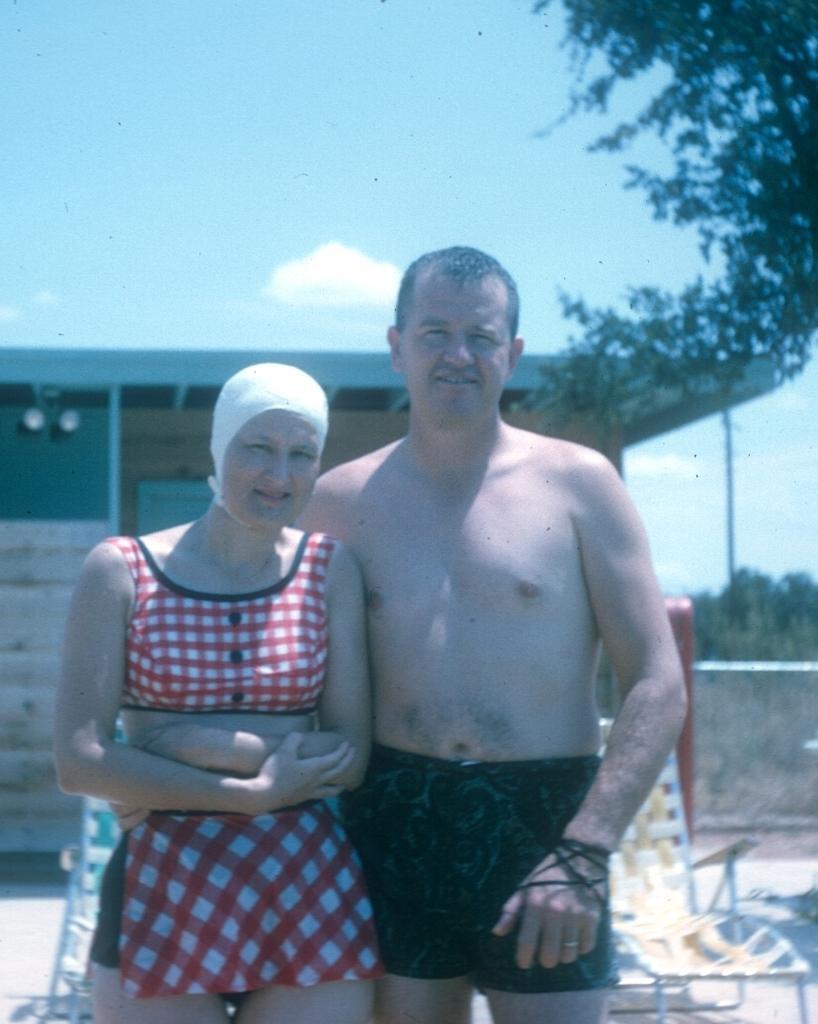Can you describe this image briefly? In this image in the foreground there is one man and one woman standing, and in the background there is a chair, building and some trees and grass. At the bottom there is walkway, and at the top there is sky. 